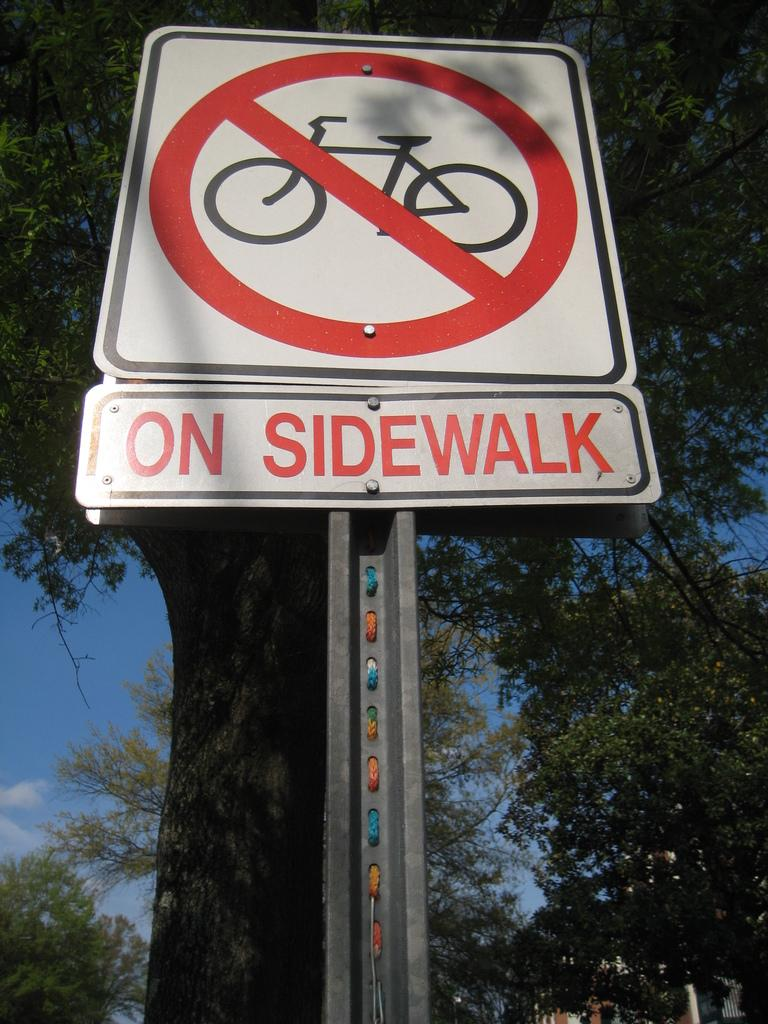<image>
Provide a brief description of the given image. a street sign with a bike icon that express no parking on sidewalk 